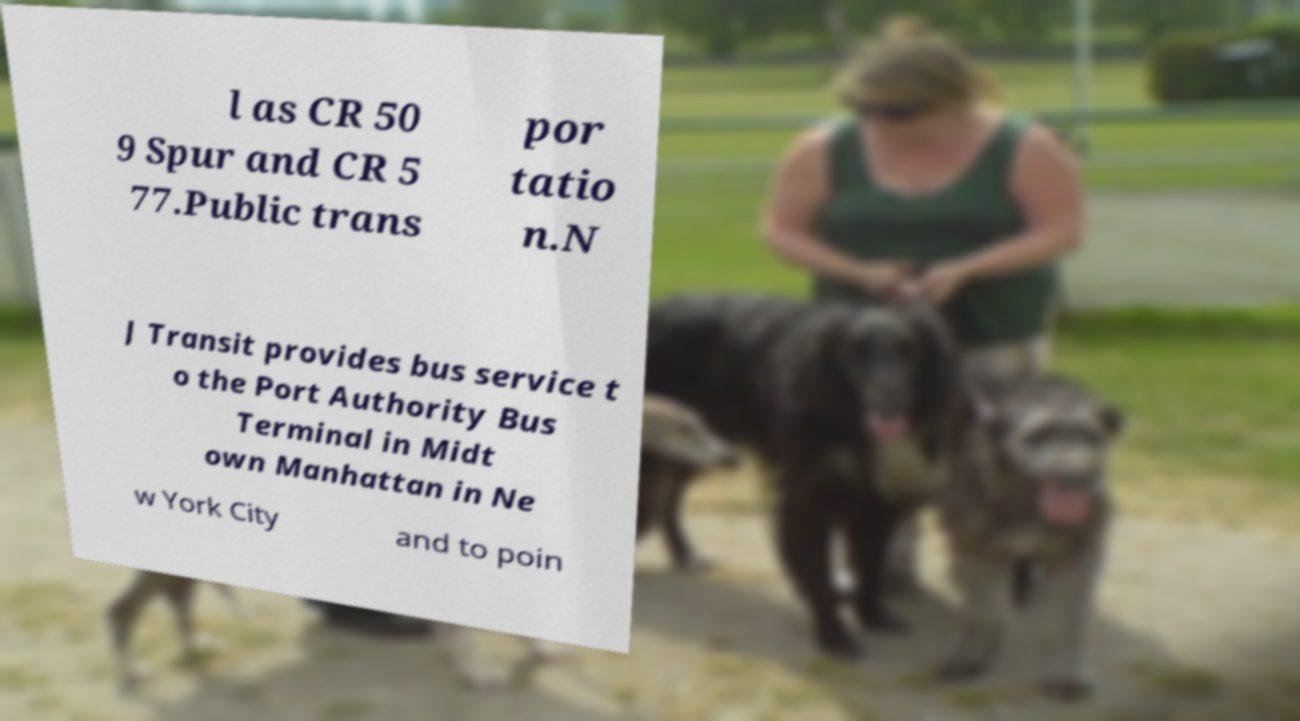Can you accurately transcribe the text from the provided image for me? l as CR 50 9 Spur and CR 5 77.Public trans por tatio n.N J Transit provides bus service t o the Port Authority Bus Terminal in Midt own Manhattan in Ne w York City and to poin 